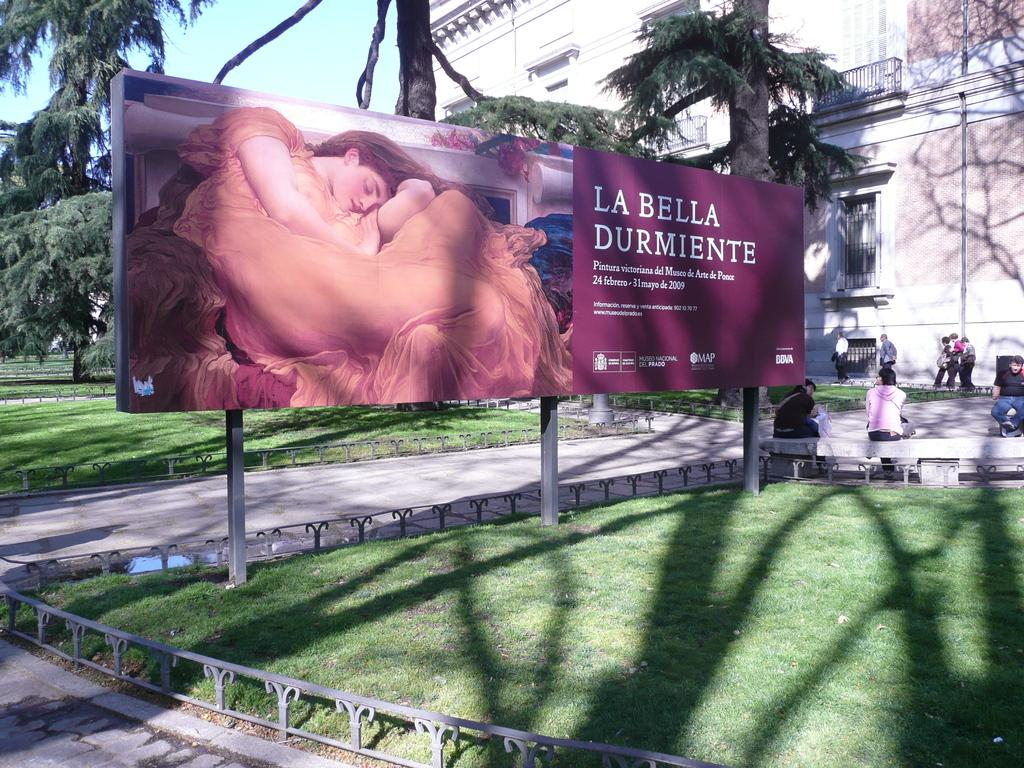<image>
Relay a brief, clear account of the picture shown. A large poster advertising La Bella Durmiente in 2009. 